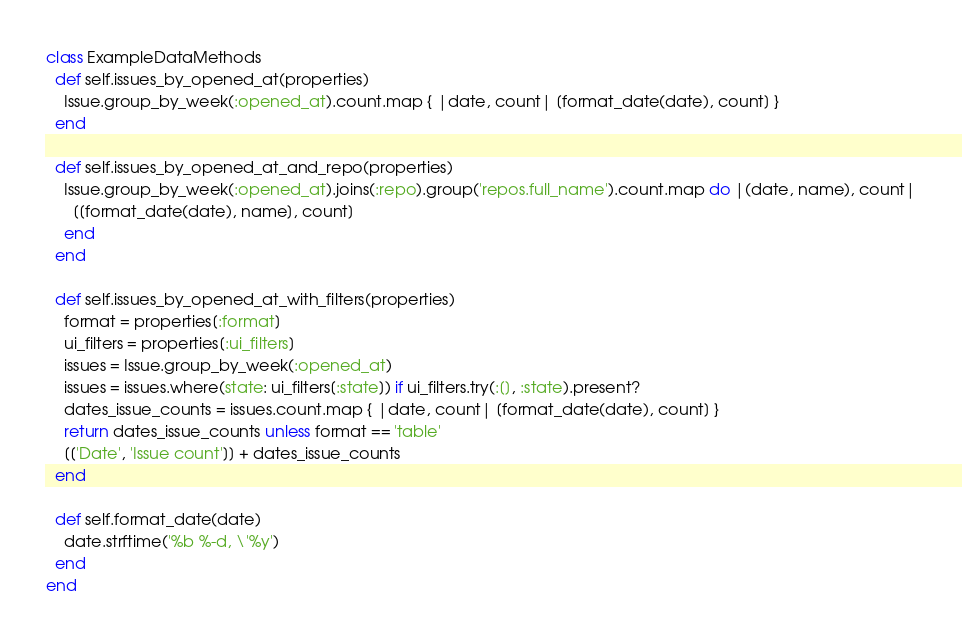<code> <loc_0><loc_0><loc_500><loc_500><_Ruby_>class ExampleDataMethods
  def self.issues_by_opened_at(properties)
    Issue.group_by_week(:opened_at).count.map { |date, count| [format_date(date), count] }
  end

  def self.issues_by_opened_at_and_repo(properties)
    Issue.group_by_week(:opened_at).joins(:repo).group('repos.full_name').count.map do |(date, name), count|
      [[format_date(date), name], count]
    end
  end

  def self.issues_by_opened_at_with_filters(properties)
    format = properties[:format]
    ui_filters = properties[:ui_filters]
    issues = Issue.group_by_week(:opened_at)
    issues = issues.where(state: ui_filters[:state]) if ui_filters.try(:[], :state).present?
    dates_issue_counts = issues.count.map { |date, count| [format_date(date), count] }
    return dates_issue_counts unless format == 'table'
    [['Date', 'Issue count']] + dates_issue_counts
  end

  def self.format_date(date)
    date.strftime('%b %-d, \'%y')
  end
end
</code> 